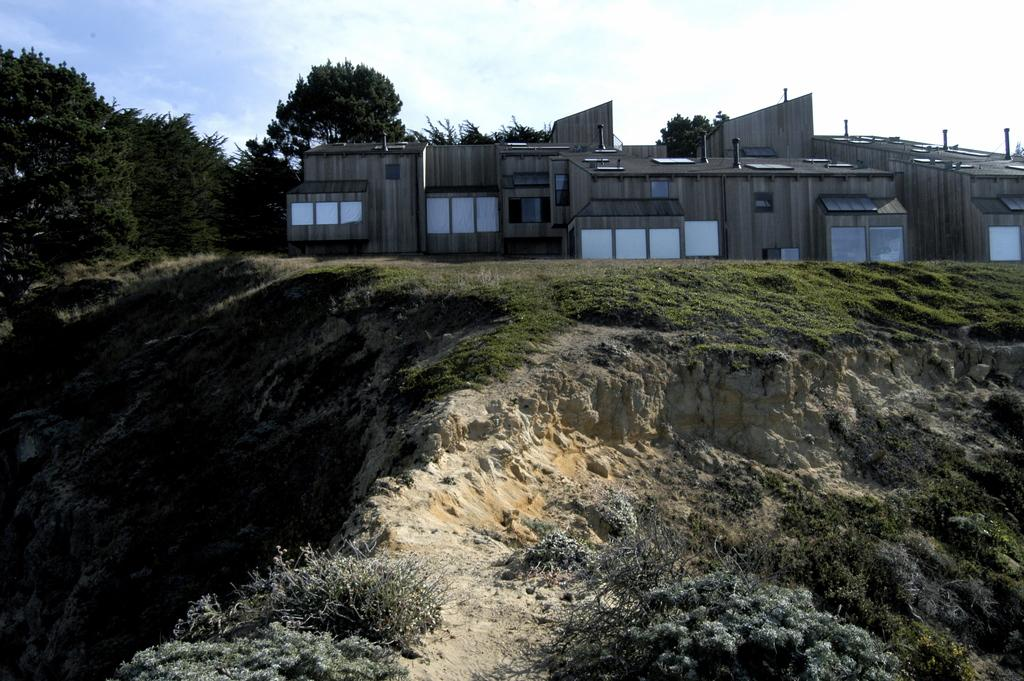What type of natural environment is visible in the image? There is grass, mountains, and trees visible in the image. What type of man-made structures can be seen in the image? There are buildings in the image. What is visible in the sky in the image? The sky is visible in the image. Can you determine the time of day the image was taken? The image was likely taken during the day, as there is no indication of darkness or artificial light. What type of lamp is hanging from the tree in the image? There is no lamp hanging from a tree in the image; it features grass, mountains, trees, buildings, and the sky. 